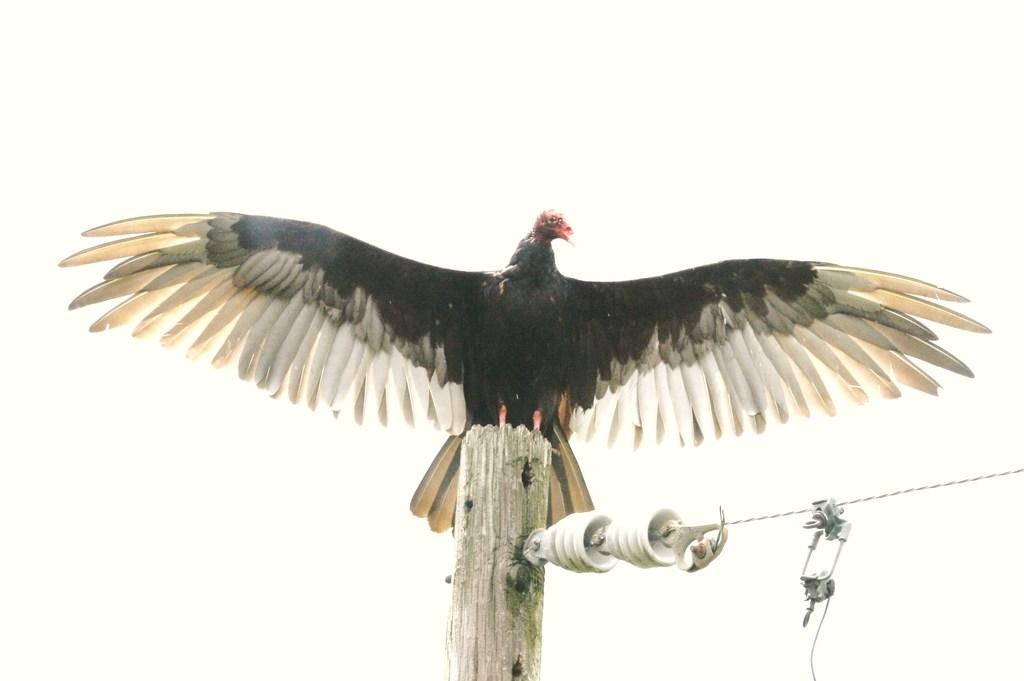What type of animal is in the picture? There is a bird in the picture. What is the bird is standing on in the picture? The bird is standing on a wooden pole. Is there anything connected to the wooden pole? Yes, there is a wire attached to the pole. What color is the horse in the picture? There is no horse present in the image; it features a bird standing on a wooden pole with a wire attached to it. How much gold is visible in the picture? There is no gold present in the image. 